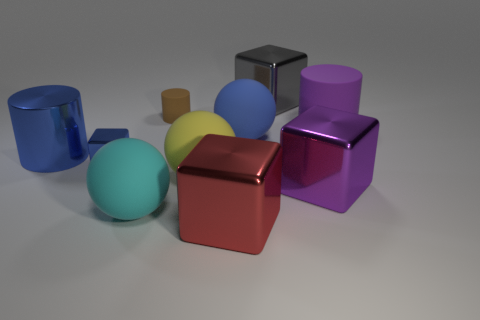Do the large ball that is behind the big blue shiny cylinder and the metal block that is on the left side of the small brown matte object have the same color?
Offer a very short reply. Yes. Does the large cyan object have the same shape as the red metallic object?
Make the answer very short. No. Is the material of the blue object behind the blue shiny cylinder the same as the blue cylinder?
Make the answer very short. No. The large thing that is behind the blue matte ball and in front of the big gray object has what shape?
Your answer should be very brief. Cylinder. Is there a big metal thing in front of the large blue object on the right side of the big red shiny block?
Provide a succinct answer. Yes. What number of other things are the same material as the small blue cube?
Keep it short and to the point. 4. Do the cyan matte object right of the big metal cylinder and the large blue matte thing that is behind the yellow matte thing have the same shape?
Your answer should be compact. Yes. Is the tiny blue cube made of the same material as the blue cylinder?
Ensure brevity in your answer.  Yes. There is a cyan matte ball that is on the right side of the large object to the left of the small thing that is in front of the blue metal cylinder; how big is it?
Your answer should be very brief. Large. What number of other objects are there of the same color as the tiny rubber thing?
Give a very brief answer. 0. 